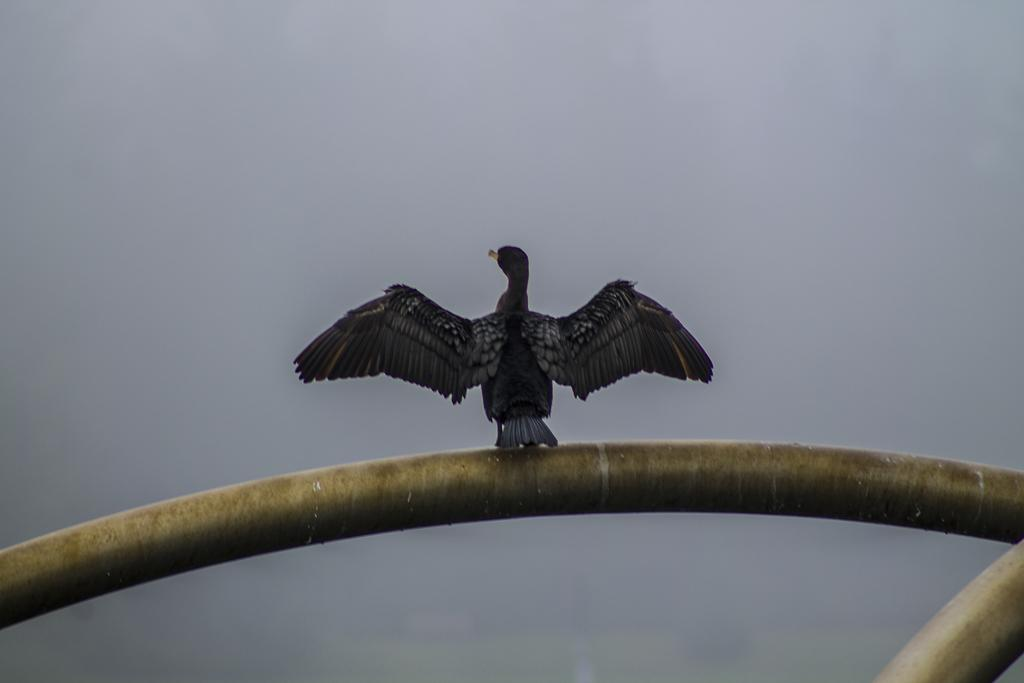What type of animal is in the image? There is a bird in the image. What color is the bird? The bird is black in color. Where is the bird located in the image? The bird is on a railing. What is the color of the railing? The railing is gold in color. What can be seen in the background of the image? There is a sky visible in the background of the image. How many rabbits can be seen hopping in the image? There are no rabbits present in the image; it features a black bird on a gold railing. What direction is the bird looking in the image? The image does not provide information about the bird's gaze or direction it is looking. 